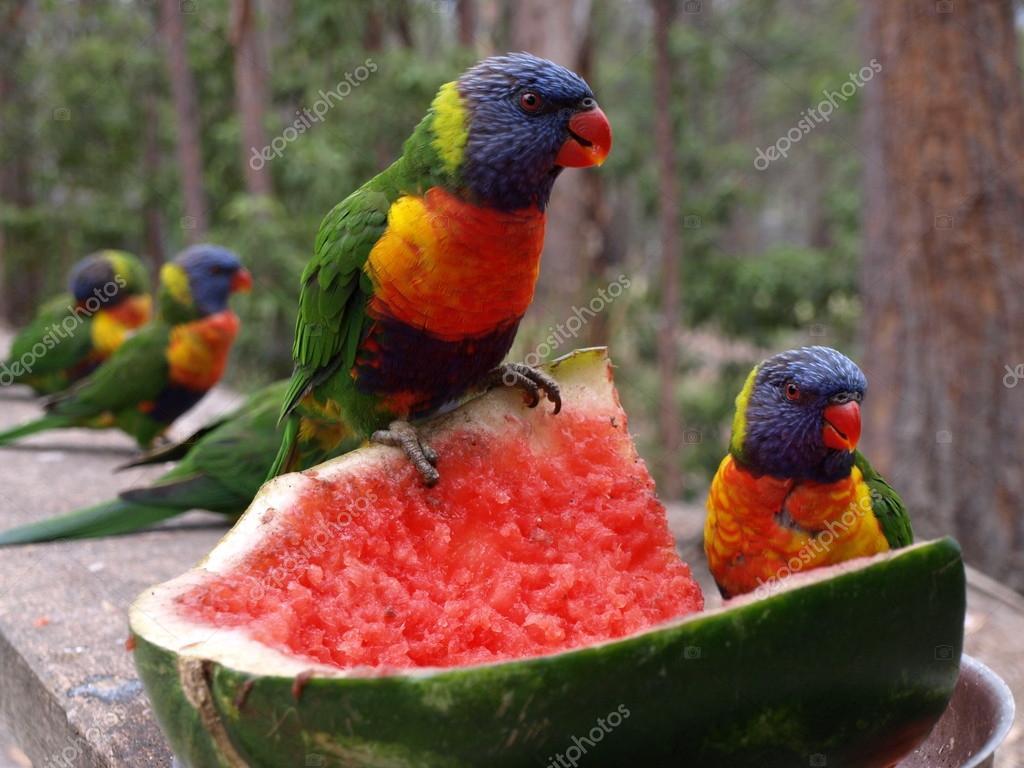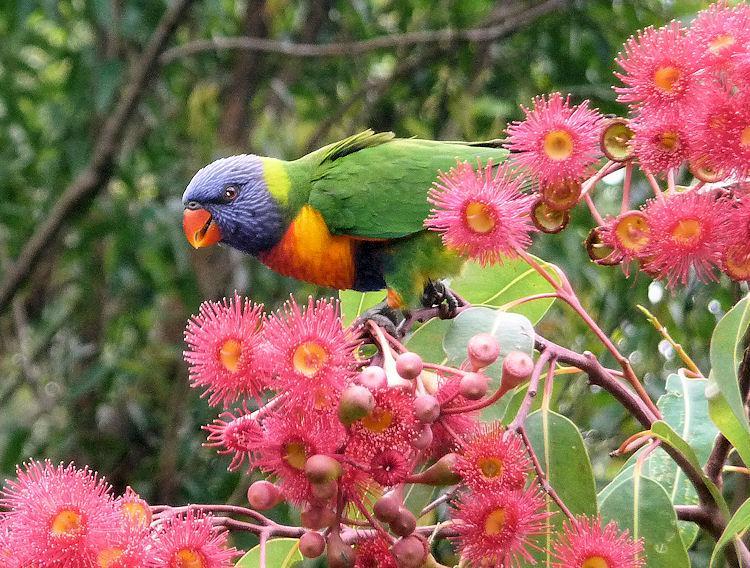The first image is the image on the left, the second image is the image on the right. Assess this claim about the two images: "In the image to the left, the bird is eating from a flower.". Correct or not? Answer yes or no. No. The first image is the image on the left, the second image is the image on the right. Assess this claim about the two images: "There is a total of 1 parrot perched on magenta colored flowers.". Correct or not? Answer yes or no. Yes. 